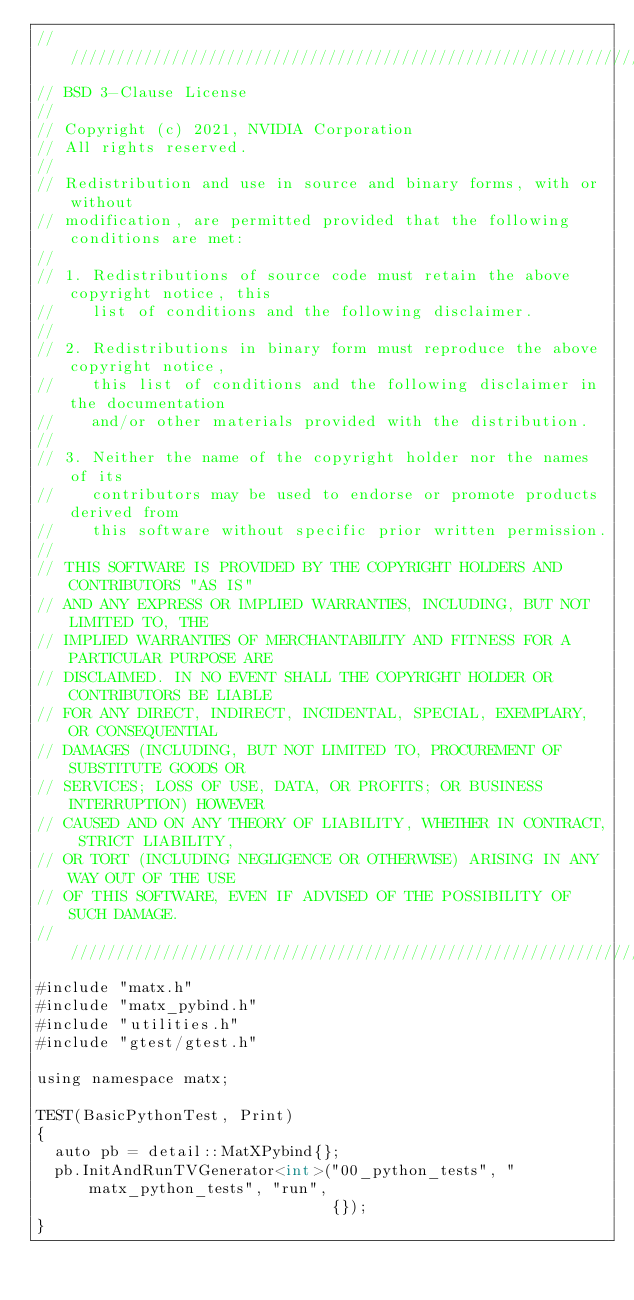<code> <loc_0><loc_0><loc_500><loc_500><_Cuda_>////////////////////////////////////////////////////////////////////////////////
// BSD 3-Clause License
//
// Copyright (c) 2021, NVIDIA Corporation
// All rights reserved.
//
// Redistribution and use in source and binary forms, with or without
// modification, are permitted provided that the following conditions are met:
//
// 1. Redistributions of source code must retain the above copyright notice, this
//    list of conditions and the following disclaimer.
//
// 2. Redistributions in binary form must reproduce the above copyright notice,
//    this list of conditions and the following disclaimer in the documentation
//    and/or other materials provided with the distribution.
//
// 3. Neither the name of the copyright holder nor the names of its
//    contributors may be used to endorse or promote products derived from
//    this software without specific prior written permission.
//
// THIS SOFTWARE IS PROVIDED BY THE COPYRIGHT HOLDERS AND CONTRIBUTORS "AS IS"
// AND ANY EXPRESS OR IMPLIED WARRANTIES, INCLUDING, BUT NOT LIMITED TO, THE
// IMPLIED WARRANTIES OF MERCHANTABILITY AND FITNESS FOR A PARTICULAR PURPOSE ARE
// DISCLAIMED. IN NO EVENT SHALL THE COPYRIGHT HOLDER OR CONTRIBUTORS BE LIABLE
// FOR ANY DIRECT, INDIRECT, INCIDENTAL, SPECIAL, EXEMPLARY, OR CONSEQUENTIAL
// DAMAGES (INCLUDING, BUT NOT LIMITED TO, PROCUREMENT OF SUBSTITUTE GOODS OR
// SERVICES; LOSS OF USE, DATA, OR PROFITS; OR BUSINESS INTERRUPTION) HOWEVER
// CAUSED AND ON ANY THEORY OF LIABILITY, WHETHER IN CONTRACT, STRICT LIABILITY,
// OR TORT (INCLUDING NEGLIGENCE OR OTHERWISE) ARISING IN ANY WAY OUT OF THE USE
// OF THIS SOFTWARE, EVEN IF ADVISED OF THE POSSIBILITY OF SUCH DAMAGE.
/////////////////////////////////////////////////////////////////////////////////
#include "matx.h"
#include "matx_pybind.h"
#include "utilities.h"
#include "gtest/gtest.h"

using namespace matx;

TEST(BasicPythonTest, Print)
{
  auto pb = detail::MatXPybind{};
  pb.InitAndRunTVGenerator<int>("00_python_tests", "matx_python_tests", "run",
                                {});
}</code> 